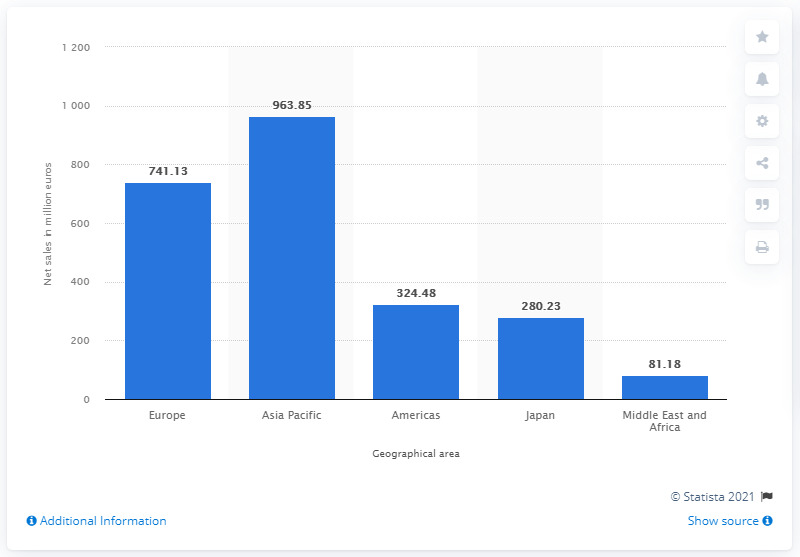Draw attention to some important aspects in this diagram. In 2020, the net sales of Prada in Europe were 741.13 million euros. 